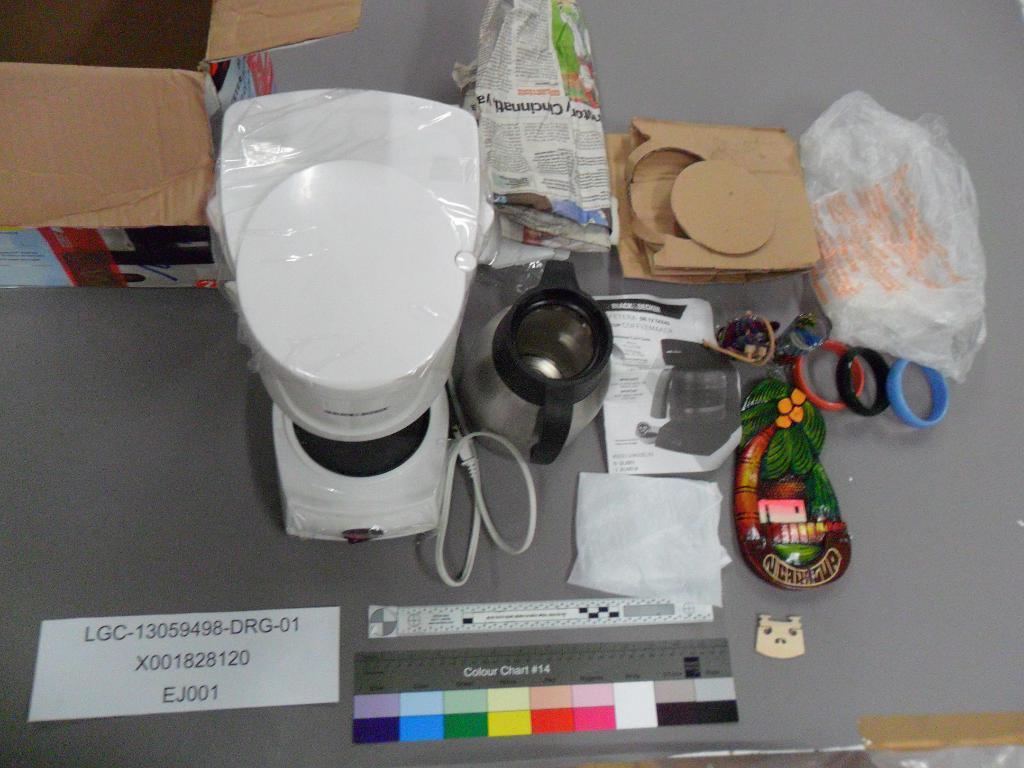What number color chart is that?
Ensure brevity in your answer.  14. 